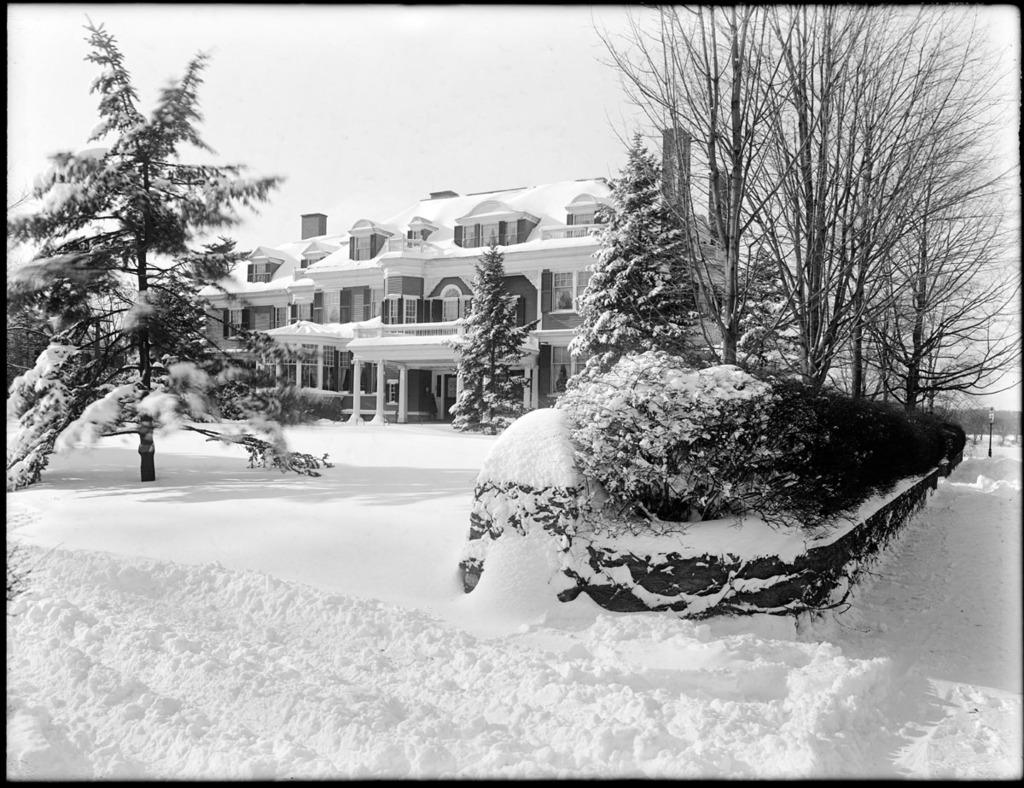What type of vegetation can be seen in the image? There are trees and bushes in the image. What type of structures are present in the image? There are buildings in the image. What is the purpose of the light pole in the image? The light pole provides illumination in the image. What is the condition of the surface at the bottom of the image? There is snow on the surface at the bottom of the image. What is visible at the top of the image? The sky is visible at the top of the image. What type of hole can be seen in the image? There is no hole present in the image. Who is the manager of the buildings in the image? The image does not provide information about the management of the buildings. 